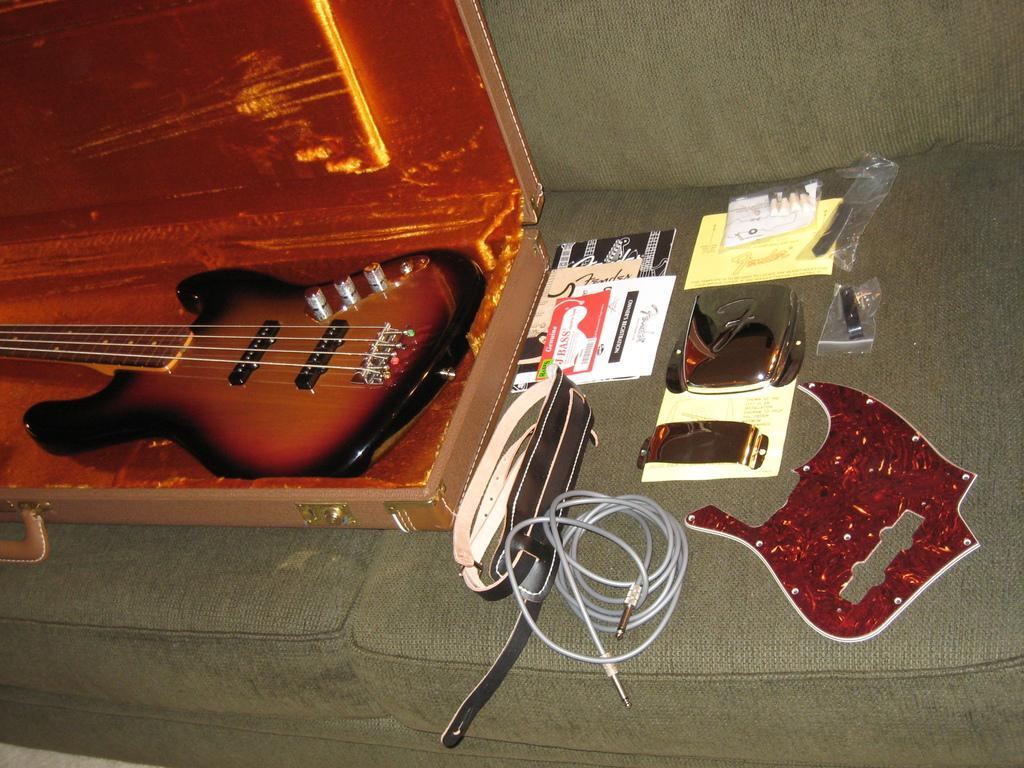Please provide a concise description of this image. This picture shows a guitar placed in a guitar box. Beside there are some accessories placed on the sofa. 